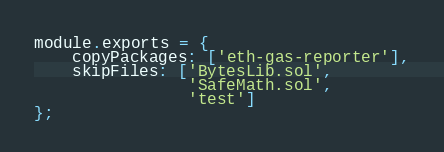<code> <loc_0><loc_0><loc_500><loc_500><_JavaScript_>module.exports = {
    copyPackages: ['eth-gas-reporter'],
    skipFiles: ['BytesLib.sol',
                'SafeMath.sol',
                'test']
};
</code> 